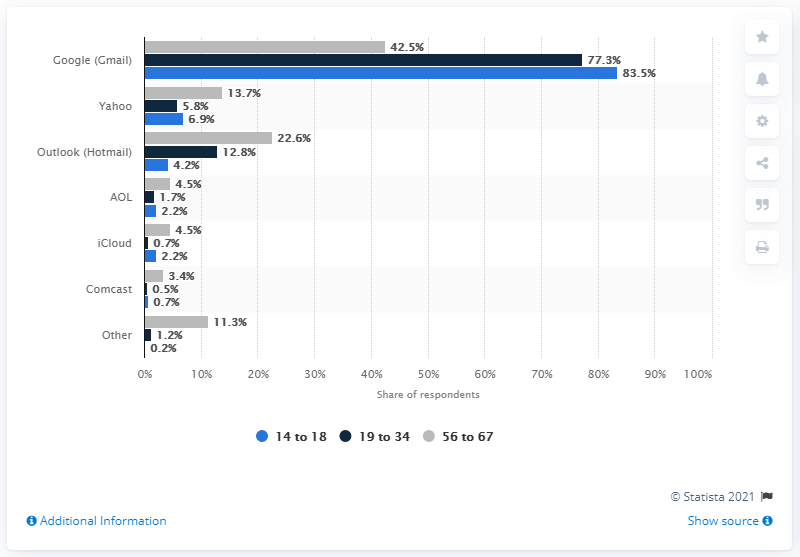Highlight a few significant elements in this photo. According to the survey, 6.9% of respondents reported using Yahoo as their primary e-mail provider. 